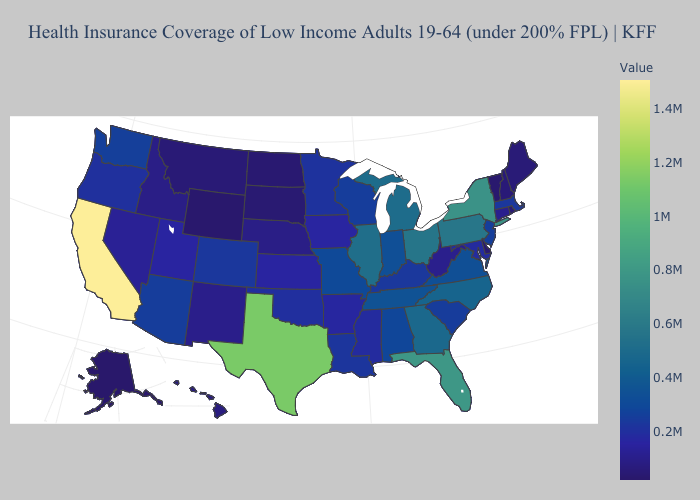Does California have the highest value in the USA?
Concise answer only. Yes. Does Massachusetts have a lower value than Ohio?
Be succinct. Yes. Does North Dakota have the lowest value in the MidWest?
Short answer required. Yes. Which states have the lowest value in the USA?
Concise answer only. Alaska. Which states have the highest value in the USA?
Keep it brief. California. 